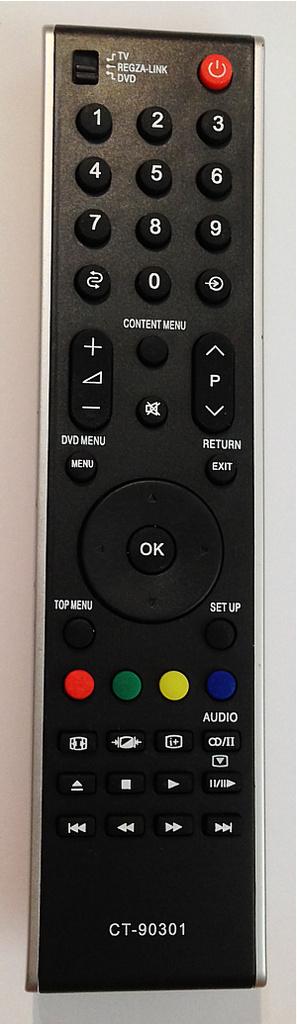What is a word feature on the control fuctions?
Make the answer very short. Audio. 